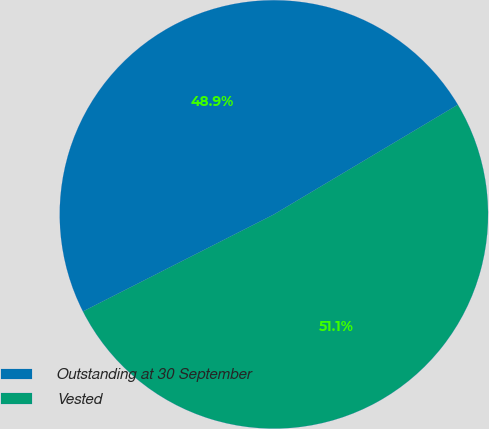Convert chart to OTSL. <chart><loc_0><loc_0><loc_500><loc_500><pie_chart><fcel>Outstanding at 30 September<fcel>Vested<nl><fcel>48.92%<fcel>51.08%<nl></chart> 